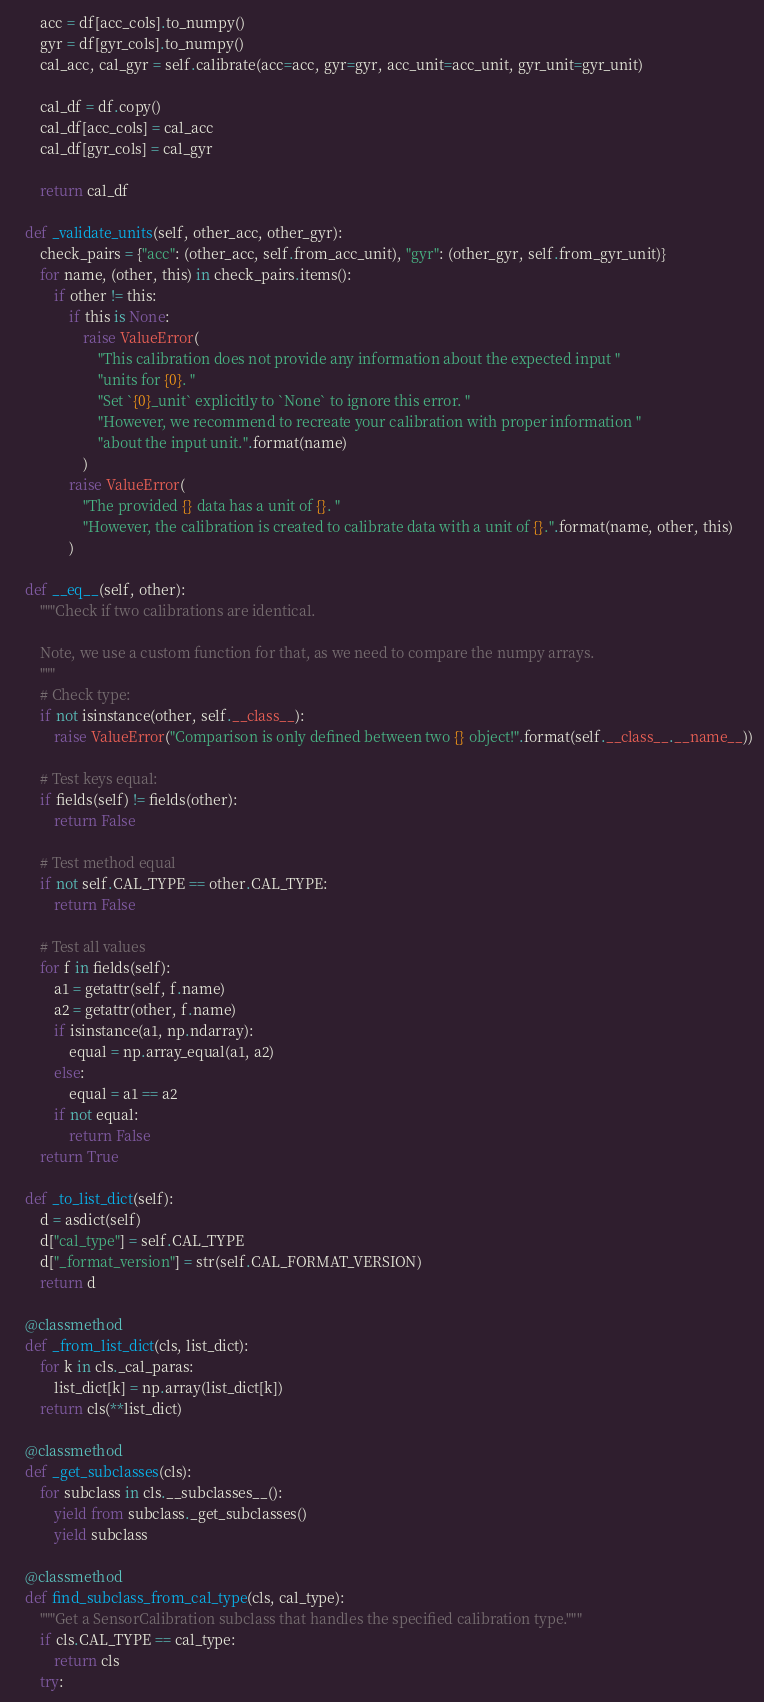Convert code to text. <code><loc_0><loc_0><loc_500><loc_500><_Python_>        acc = df[acc_cols].to_numpy()
        gyr = df[gyr_cols].to_numpy()
        cal_acc, cal_gyr = self.calibrate(acc=acc, gyr=gyr, acc_unit=acc_unit, gyr_unit=gyr_unit)

        cal_df = df.copy()
        cal_df[acc_cols] = cal_acc
        cal_df[gyr_cols] = cal_gyr

        return cal_df

    def _validate_units(self, other_acc, other_gyr):
        check_pairs = {"acc": (other_acc, self.from_acc_unit), "gyr": (other_gyr, self.from_gyr_unit)}
        for name, (other, this) in check_pairs.items():
            if other != this:
                if this is None:
                    raise ValueError(
                        "This calibration does not provide any information about the expected input "
                        "units for {0}. "
                        "Set `{0}_unit` explicitly to `None` to ignore this error. "
                        "However, we recommend to recreate your calibration with proper information "
                        "about the input unit.".format(name)
                    )
                raise ValueError(
                    "The provided {} data has a unit of {}. "
                    "However, the calibration is created to calibrate data with a unit of {}.".format(name, other, this)
                )

    def __eq__(self, other):
        """Check if two calibrations are identical.

        Note, we use a custom function for that, as we need to compare the numpy arrays.
        """
        # Check type:
        if not isinstance(other, self.__class__):
            raise ValueError("Comparison is only defined between two {} object!".format(self.__class__.__name__))

        # Test keys equal:
        if fields(self) != fields(other):
            return False

        # Test method equal
        if not self.CAL_TYPE == other.CAL_TYPE:
            return False

        # Test all values
        for f in fields(self):
            a1 = getattr(self, f.name)
            a2 = getattr(other, f.name)
            if isinstance(a1, np.ndarray):
                equal = np.array_equal(a1, a2)
            else:
                equal = a1 == a2
            if not equal:
                return False
        return True

    def _to_list_dict(self):
        d = asdict(self)
        d["cal_type"] = self.CAL_TYPE
        d["_format_version"] = str(self.CAL_FORMAT_VERSION)
        return d

    @classmethod
    def _from_list_dict(cls, list_dict):
        for k in cls._cal_paras:
            list_dict[k] = np.array(list_dict[k])
        return cls(**list_dict)

    @classmethod
    def _get_subclasses(cls):
        for subclass in cls.__subclasses__():
            yield from subclass._get_subclasses()
            yield subclass

    @classmethod
    def find_subclass_from_cal_type(cls, cal_type):
        """Get a SensorCalibration subclass that handles the specified calibration type."""
        if cls.CAL_TYPE == cal_type:
            return cls
        try:</code> 